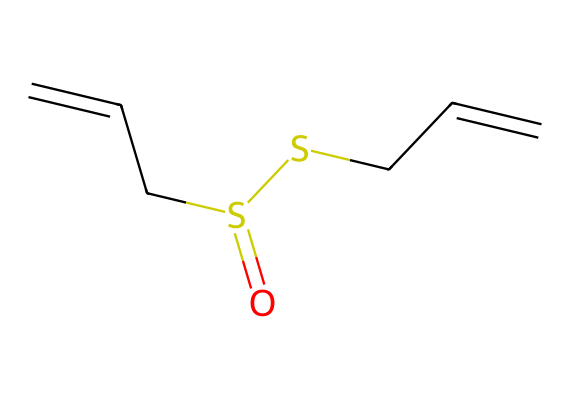What is the main functional group present in this compound? The structure includes a sulfur atom connected to oxygen through a double bond (S(=O)), indicating a sulfonyl group, which is characteristic of organosulfur compounds.
Answer: sulfonyl How many carbon atoms are in the molecular structure? By analyzing the SMILES representation, there are four carbon atoms denoted by 'C' in the sequence, confirming the total count.
Answer: four How many double bonds are present in this molecule? The given SMILES shows two instances of ‘C=C’ which indicate double bonds between carbon atoms, thus confirming there are two double bonds.
Answer: two What is the overall molecular formula derived from this SMILES representation? By counting the atoms represented in the SMILES, we identify four carbons, eight hydrogens, two sulfurs, and one oxygen, leading to the formula C4H8S2O.
Answer: C4H8S2O Which part of the molecule would contribute most to its antimicrobial properties? The presence of the sulfur atoms is often associated with the bioactivity of organosulfur compounds, offering antimicrobial effects in this structure.
Answer: sulfur What is the type of reaction that this compound primarily participates in? Organosulfur compounds like allicin often participate in reactions involving nucleophilic substitution due to their sulfonyl group, allowing easy reaction with various nucleophiles.
Answer: nucleophilic substitution 